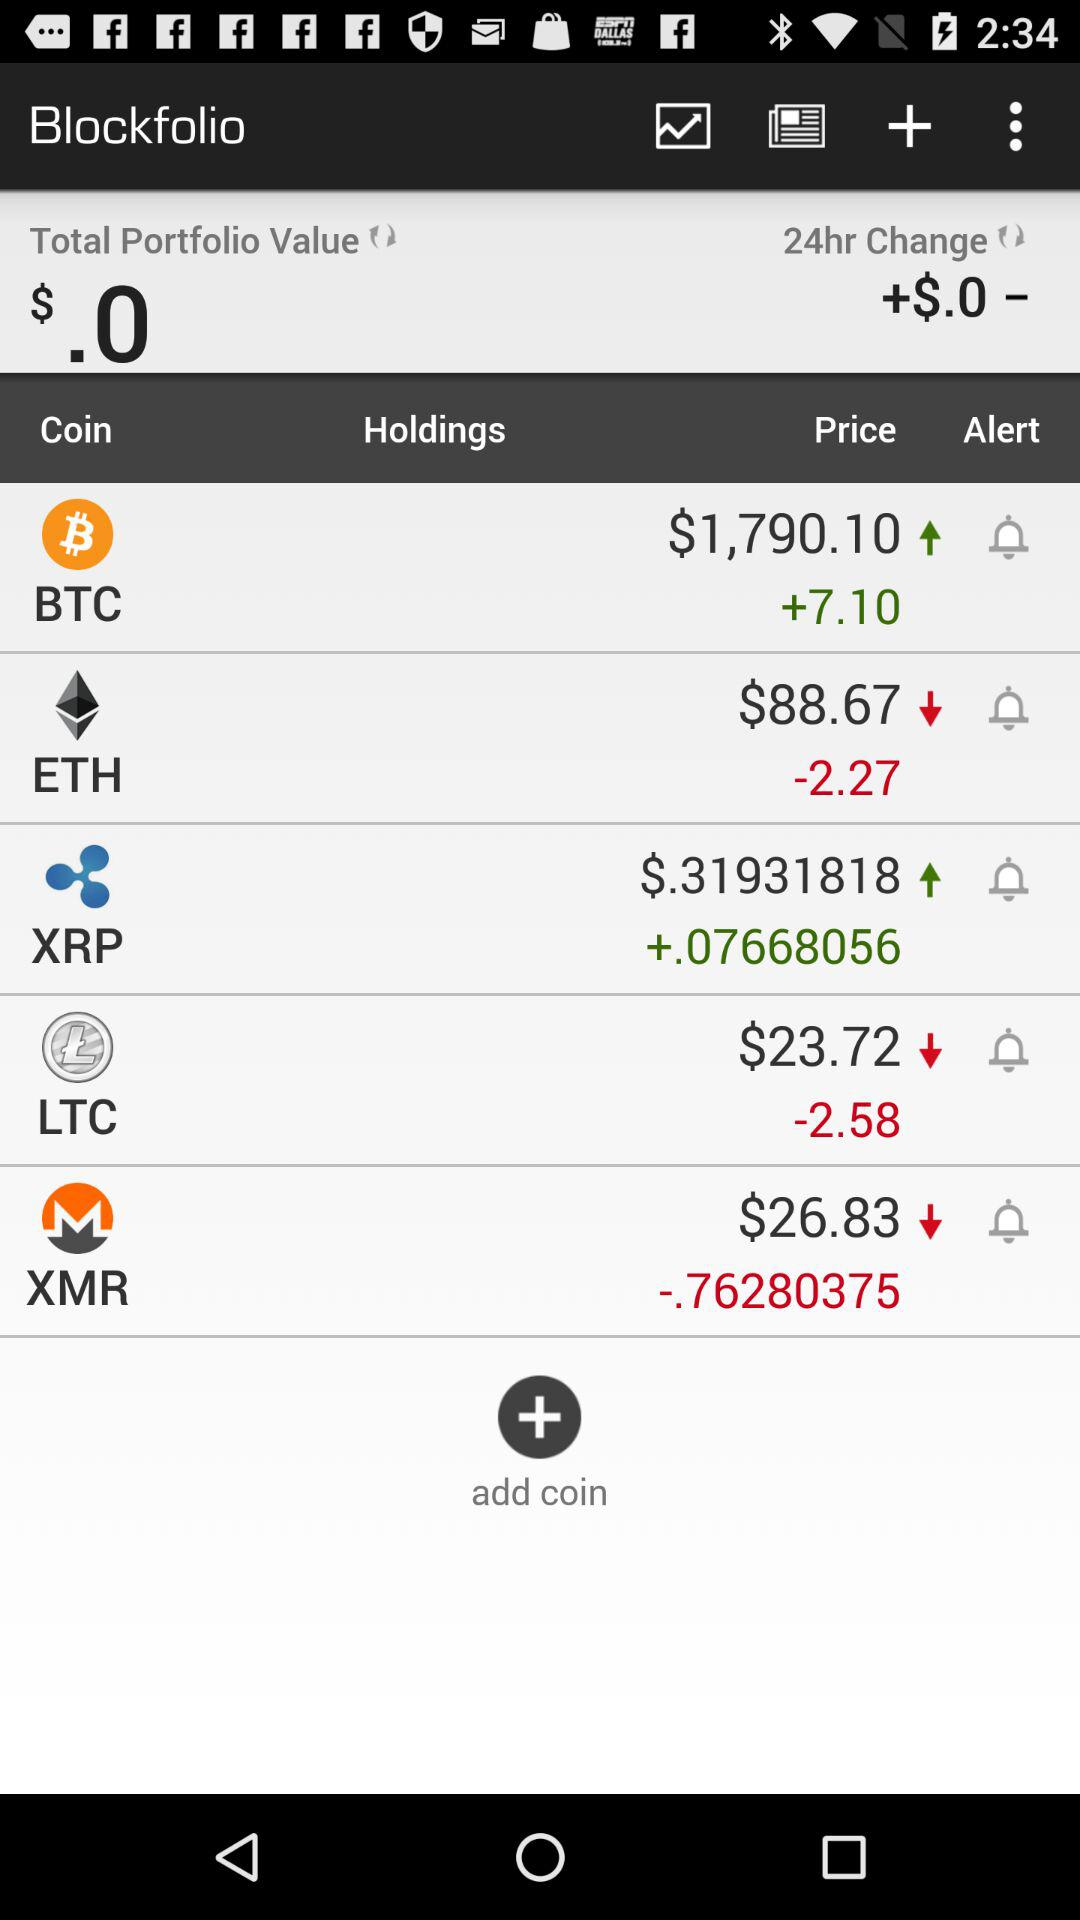What is the application name? The application name is "Blockfolio". 